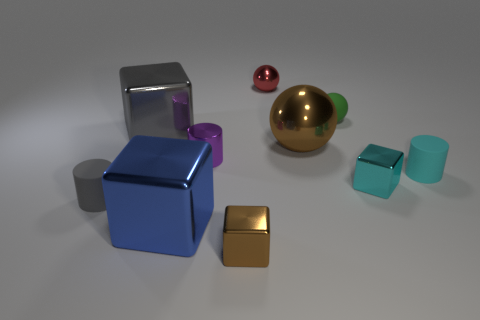What number of other brown metallic things are the same shape as the big brown metallic object?
Give a very brief answer. 0. Are there an equal number of small shiny things that are behind the tiny red object and big red shiny cylinders?
Ensure brevity in your answer.  Yes. There is a purple shiny thing that is the same size as the gray rubber object; what is its shape?
Provide a succinct answer. Cylinder. Are there any tiny cyan objects of the same shape as the tiny purple metallic object?
Your response must be concise. Yes. There is a brown thing that is behind the small metal cube that is on the left side of the cyan shiny block; is there a small ball that is to the right of it?
Your answer should be compact. Yes. Are there more tiny cylinders that are on the left side of the brown block than metal objects that are on the right side of the large gray shiny cube?
Provide a short and direct response. No. What is the material of the gray cylinder that is the same size as the green rubber object?
Your answer should be very brief. Rubber. How many tiny things are gray objects or shiny spheres?
Your answer should be very brief. 2. Is the shape of the tiny cyan rubber object the same as the tiny gray object?
Ensure brevity in your answer.  Yes. What number of shiny things are behind the blue metal cube and in front of the large metal ball?
Offer a terse response. 2. 